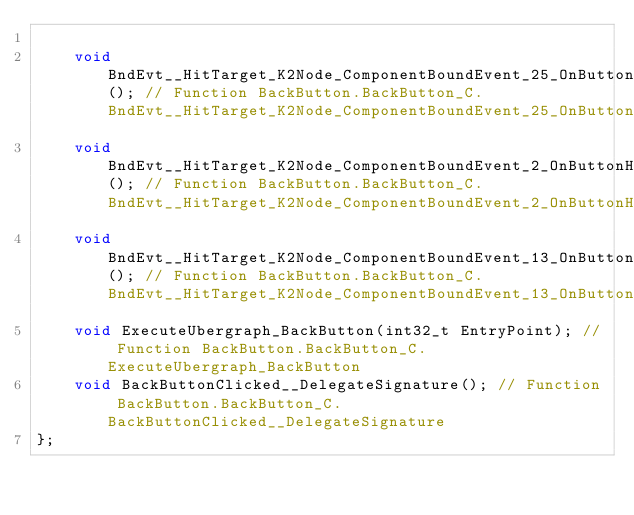Convert code to text. <code><loc_0><loc_0><loc_500><loc_500><_C_>
	void BndEvt__HitTarget_K2Node_ComponentBoundEvent_25_OnButtonClickedEvent__DelegateSignature(); // Function BackButton.BackButton_C.BndEvt__HitTarget_K2Node_ComponentBoundEvent_25_OnButtonClickedEvent__DelegateSignature
	void BndEvt__HitTarget_K2Node_ComponentBoundEvent_2_OnButtonHoverEvent__DelegateSignature(); // Function BackButton.BackButton_C.BndEvt__HitTarget_K2Node_ComponentBoundEvent_2_OnButtonHoverEvent__DelegateSignature
	void BndEvt__HitTarget_K2Node_ComponentBoundEvent_13_OnButtonHoverEvent__DelegateSignature(); // Function BackButton.BackButton_C.BndEvt__HitTarget_K2Node_ComponentBoundEvent_13_OnButtonHoverEvent__DelegateSignature
	void ExecuteUbergraph_BackButton(int32_t EntryPoint); // Function BackButton.BackButton_C.ExecuteUbergraph_BackButton
	void BackButtonClicked__DelegateSignature(); // Function BackButton.BackButton_C.BackButtonClicked__DelegateSignature
};

</code> 